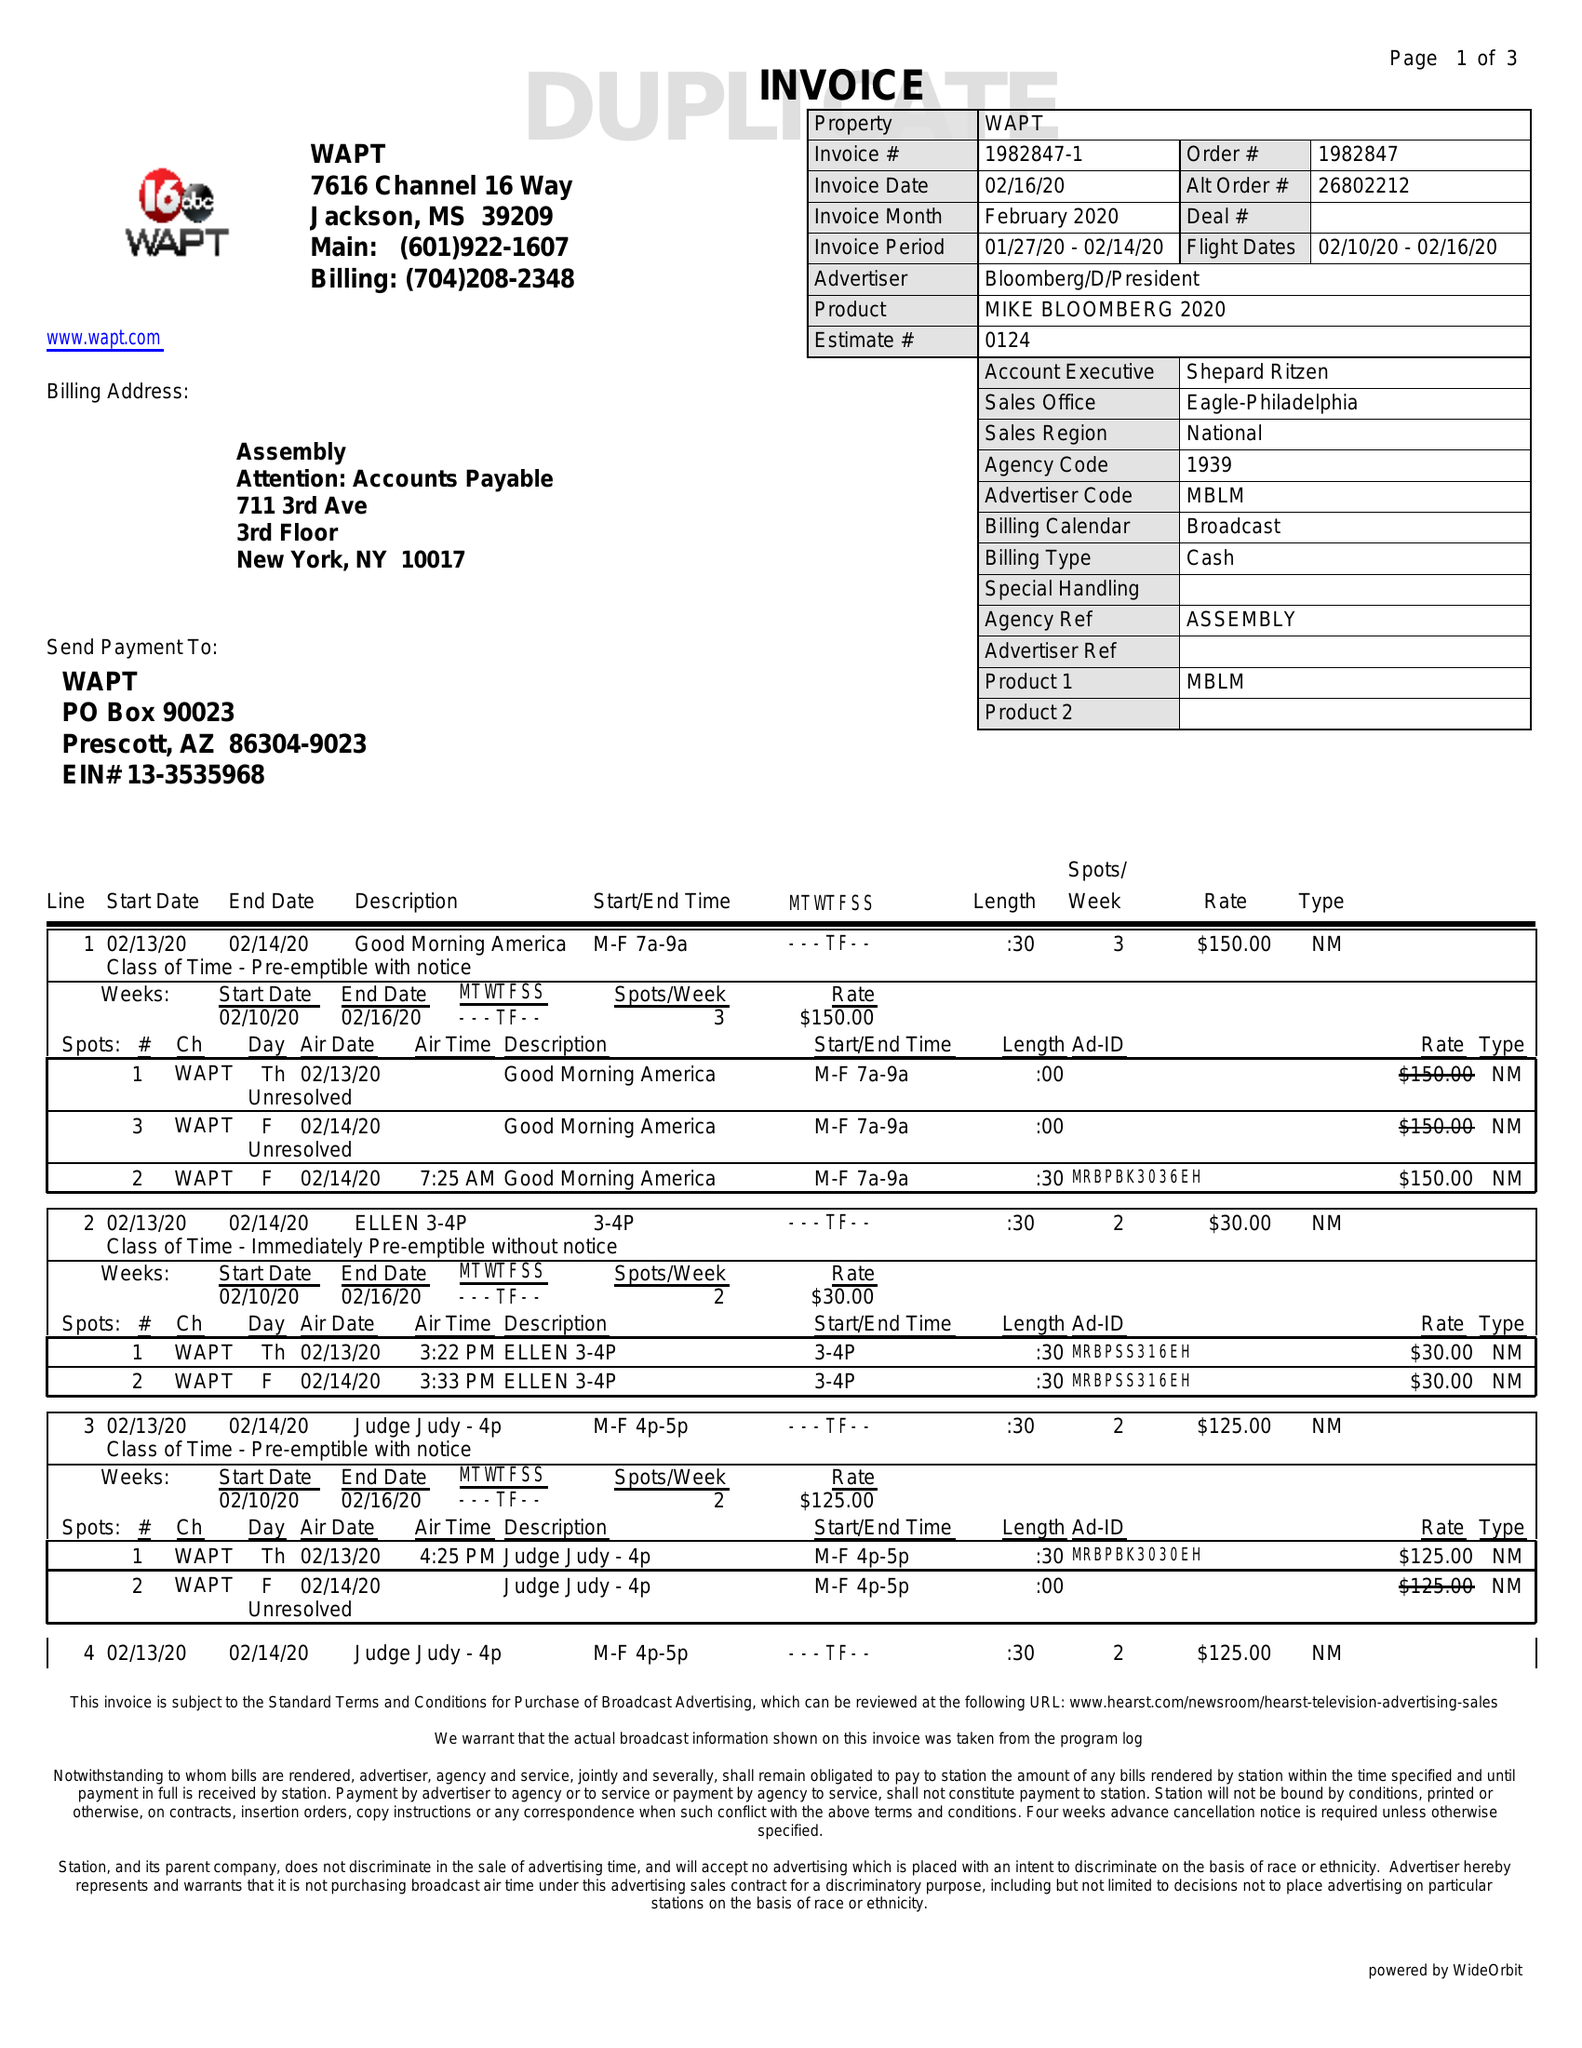What is the value for the flight_to?
Answer the question using a single word or phrase. 02/16/20 